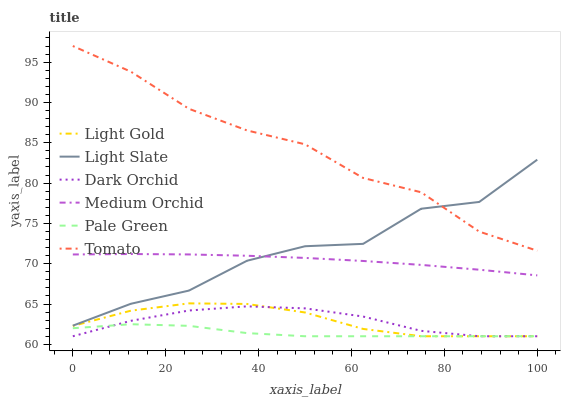Does Pale Green have the minimum area under the curve?
Answer yes or no. Yes. Does Tomato have the maximum area under the curve?
Answer yes or no. Yes. Does Light Slate have the minimum area under the curve?
Answer yes or no. No. Does Light Slate have the maximum area under the curve?
Answer yes or no. No. Is Medium Orchid the smoothest?
Answer yes or no. Yes. Is Light Slate the roughest?
Answer yes or no. Yes. Is Light Slate the smoothest?
Answer yes or no. No. Is Medium Orchid the roughest?
Answer yes or no. No. Does Dark Orchid have the lowest value?
Answer yes or no. Yes. Does Light Slate have the lowest value?
Answer yes or no. No. Does Tomato have the highest value?
Answer yes or no. Yes. Does Light Slate have the highest value?
Answer yes or no. No. Is Light Gold less than Light Slate?
Answer yes or no. Yes. Is Medium Orchid greater than Dark Orchid?
Answer yes or no. Yes. Does Light Slate intersect Tomato?
Answer yes or no. Yes. Is Light Slate less than Tomato?
Answer yes or no. No. Is Light Slate greater than Tomato?
Answer yes or no. No. Does Light Gold intersect Light Slate?
Answer yes or no. No. 